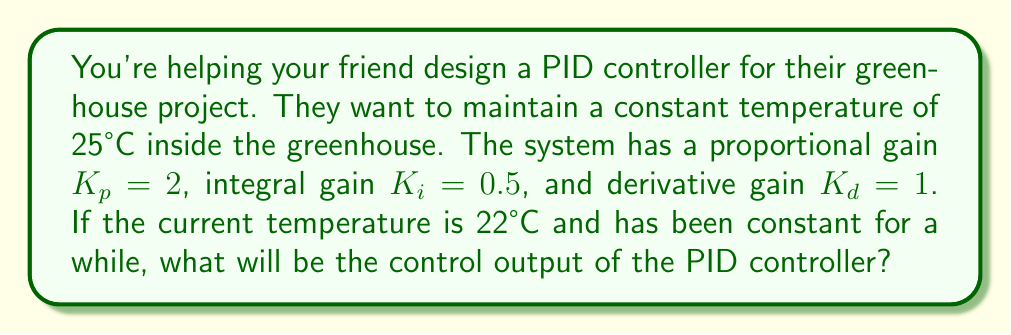Help me with this question. Let's approach this step-by-step:

1) The PID controller output is given by the equation:

   $$u(t) = K_p e(t) + K_i \int_0^t e(\tau) d\tau + K_d \frac{de(t)}{dt}$$

   where $e(t)$ is the error (difference between setpoint and current value).

2) Calculate the error:
   $e(t) = \text{setpoint} - \text{current temperature} = 25°C - 22°C = 3°C$

3) For the proportional term:
   $K_p e(t) = 2 \cdot 3 = 6$

4) For the integral term:
   Since the temperature has been constant for a while, we can assume the error has been constant. Let's say it's been constant for time $T$. Then:
   $$K_i \int_0^t e(\tau) d\tau = K_i \cdot 3 \cdot T = 0.5 \cdot 3 \cdot T = 1.5T$$

5) For the derivative term:
   Since the temperature has been constant, the rate of change of error is zero:
   $$K_d \frac{de(t)}{dt} = 1 \cdot 0 = 0$$

6) Summing up all terms:
   $$u(t) = 6 + 1.5T + 0 = 6 + 1.5T$$

The control output will increase linearly with time due to the integral term.
Answer: $u(t) = 6 + 1.5T$, where $T$ is the time the error has been constant. 